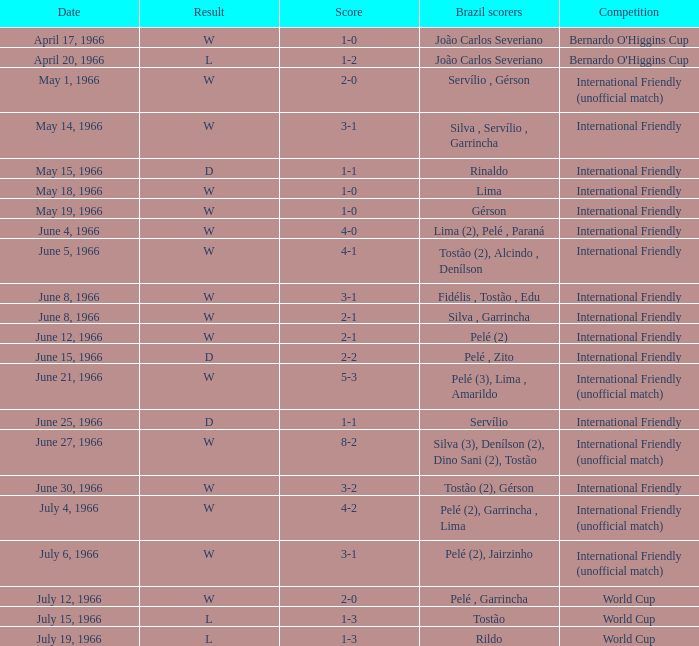What competition has a result of W on June 30, 1966? International Friendly. 